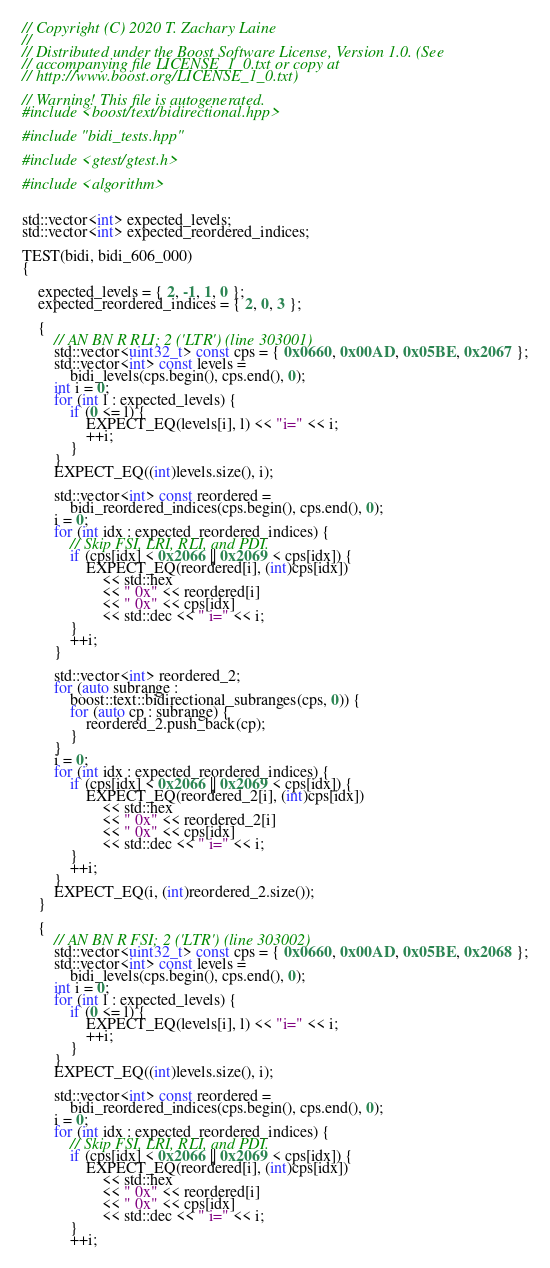Convert code to text. <code><loc_0><loc_0><loc_500><loc_500><_C++_>// Copyright (C) 2020 T. Zachary Laine
//
// Distributed under the Boost Software License, Version 1.0. (See
// accompanying file LICENSE_1_0.txt or copy at
// http://www.boost.org/LICENSE_1_0.txt)

// Warning! This file is autogenerated.
#include <boost/text/bidirectional.hpp>

#include "bidi_tests.hpp"

#include <gtest/gtest.h>

#include <algorithm>


std::vector<int> expected_levels;
std::vector<int> expected_reordered_indices;

TEST(bidi, bidi_606_000)
{

    expected_levels = { 2, -1, 1, 0 };
    expected_reordered_indices = { 2, 0, 3 };

    {
        // AN BN R RLI; 2 ('LTR') (line 303001)
        std::vector<uint32_t> const cps = { 0x0660, 0x00AD, 0x05BE, 0x2067 };
        std::vector<int> const levels =
            bidi_levels(cps.begin(), cps.end(), 0);
        int i = 0;
        for (int l : expected_levels) {
            if (0 <= l) {
                EXPECT_EQ(levels[i], l) << "i=" << i;
                ++i;
            }
        }
        EXPECT_EQ((int)levels.size(), i);

        std::vector<int> const reordered =
            bidi_reordered_indices(cps.begin(), cps.end(), 0);
        i = 0;
        for (int idx : expected_reordered_indices) {
            // Skip FSI, LRI, RLI, and PDI.
            if (cps[idx] < 0x2066 || 0x2069 < cps[idx]) {
                EXPECT_EQ(reordered[i], (int)cps[idx])
                    << std::hex
                    << " 0x" << reordered[i]
                    << " 0x" << cps[idx]
                    << std::dec << " i=" << i;
            }
            ++i;
        }

        std::vector<int> reordered_2;
        for (auto subrange :
            boost::text::bidirectional_subranges(cps, 0)) {
            for (auto cp : subrange) {
                reordered_2.push_back(cp);
            }
        }
        i = 0;
        for (int idx : expected_reordered_indices) {
            if (cps[idx] < 0x2066 || 0x2069 < cps[idx]) {
                EXPECT_EQ(reordered_2[i], (int)cps[idx])
                    << std::hex
                    << " 0x" << reordered_2[i]
                    << " 0x" << cps[idx]
                    << std::dec << " i=" << i;
            }
            ++i;
        }
        EXPECT_EQ(i, (int)reordered_2.size());
    }

    {
        // AN BN R FSI; 2 ('LTR') (line 303002)
        std::vector<uint32_t> const cps = { 0x0660, 0x00AD, 0x05BE, 0x2068 };
        std::vector<int> const levels =
            bidi_levels(cps.begin(), cps.end(), 0);
        int i = 0;
        for (int l : expected_levels) {
            if (0 <= l) {
                EXPECT_EQ(levels[i], l) << "i=" << i;
                ++i;
            }
        }
        EXPECT_EQ((int)levels.size(), i);

        std::vector<int> const reordered =
            bidi_reordered_indices(cps.begin(), cps.end(), 0);
        i = 0;
        for (int idx : expected_reordered_indices) {
            // Skip FSI, LRI, RLI, and PDI.
            if (cps[idx] < 0x2066 || 0x2069 < cps[idx]) {
                EXPECT_EQ(reordered[i], (int)cps[idx])
                    << std::hex
                    << " 0x" << reordered[i]
                    << " 0x" << cps[idx]
                    << std::dec << " i=" << i;
            }
            ++i;</code> 